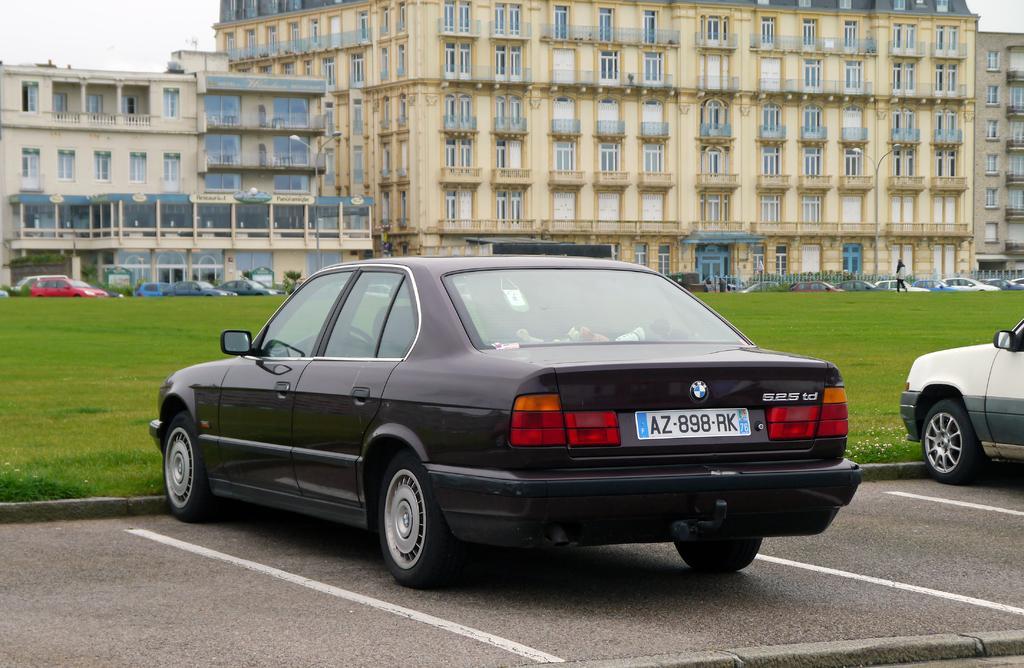Describe this image in one or two sentences. In this image I can see two cars on the road. To the side of the cars I can see the ground. In the back I can see many cars which are colorful. To the side of the cars I can see the railing, building and the sky. 